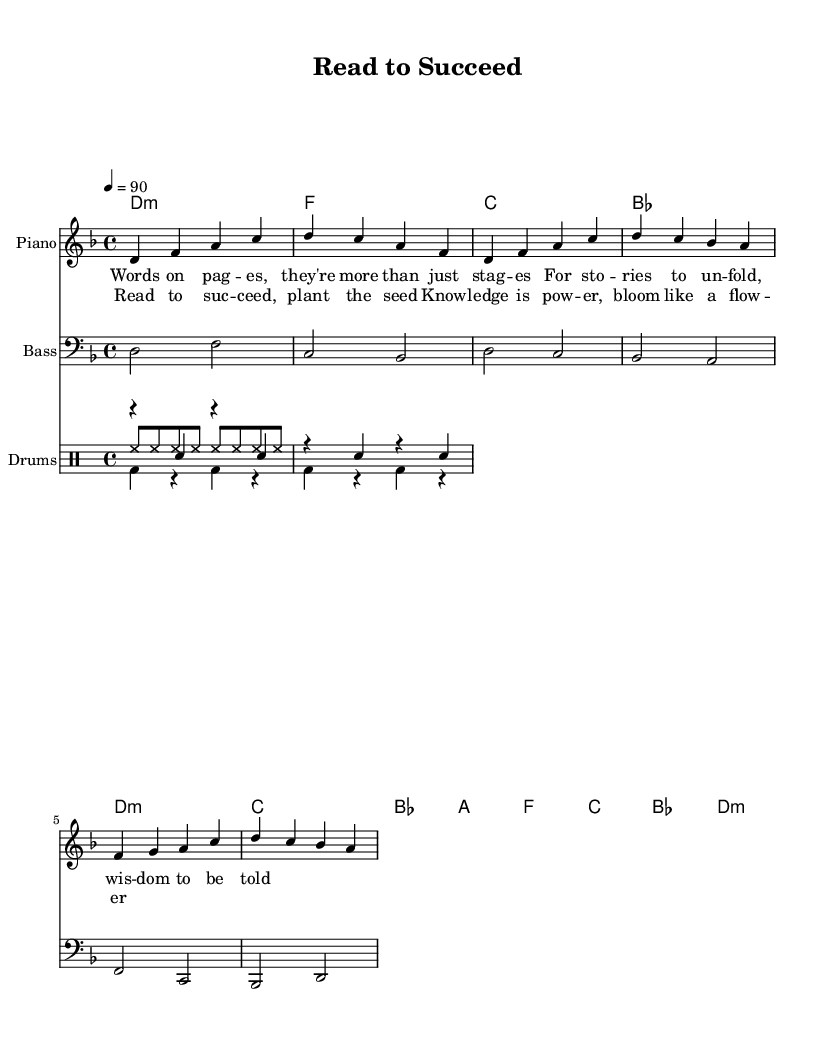What is the key signature of this music? The key signature is D minor, which contains one flat (B flat) and is indicated at the beginning of the staff.
Answer: D minor What is the time signature of this piece? The time signature is shown at the beginning of the staff as 4/4, which means there are four beats in each measure and the quarter note gets one beat.
Answer: 4/4 What is the tempo marking for this music? The tempo marking is indicated as a quarter note equals 90 beats per minute, which suggests the speed at which the music should be played.
Answer: 90 How many measures are in the verse section? The verse section consists of two measures as outlined in the sheet music under the melody part.
Answer: 2 What type of mood does the choice of D minor convey in this hip hop piece? The choice of D minor often conveys a serious and reflective mood, which aligns with the conscious rap theme emphasizing literature and reading.
Answer: Serious What rhythmic pattern is used in the snare drum part? The snare drum part alternates between rests and hits occurring every beat, providing a steady backbeat typical for hip hop music.
Answer: Steady backbeat What is the main theme explored in the lyrics? The lyrics highlight the importance of reading and the wisdom gained from literature, aligning with the conscious hip hop message.
Answer: Importance of reading 